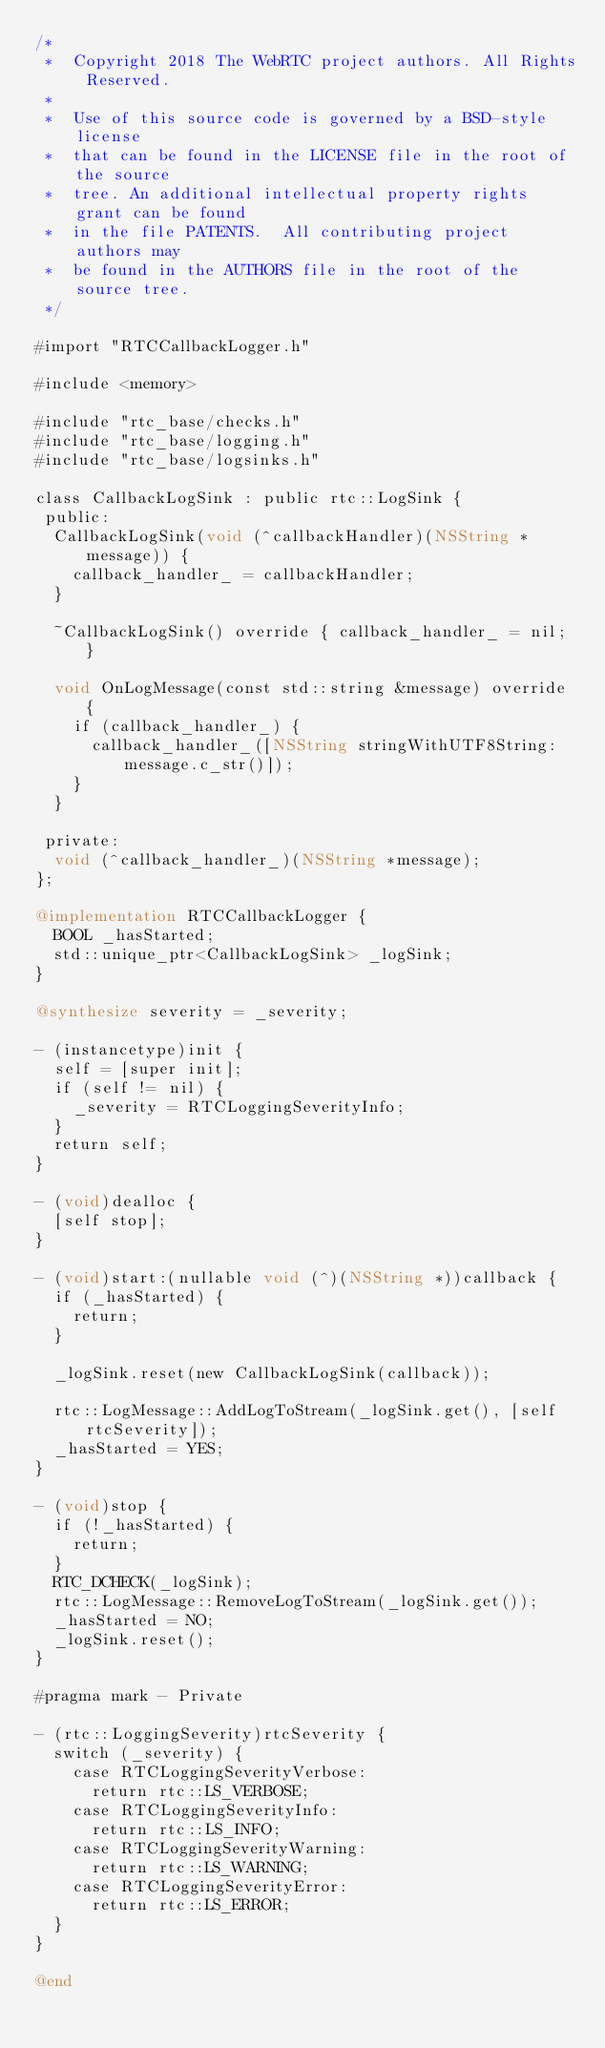<code> <loc_0><loc_0><loc_500><loc_500><_ObjectiveC_>/*
 *  Copyright 2018 The WebRTC project authors. All Rights Reserved.
 *
 *  Use of this source code is governed by a BSD-style license
 *  that can be found in the LICENSE file in the root of the source
 *  tree. An additional intellectual property rights grant can be found
 *  in the file PATENTS.  All contributing project authors may
 *  be found in the AUTHORS file in the root of the source tree.
 */

#import "RTCCallbackLogger.h"

#include <memory>

#include "rtc_base/checks.h"
#include "rtc_base/logging.h"
#include "rtc_base/logsinks.h"

class CallbackLogSink : public rtc::LogSink {
 public:
  CallbackLogSink(void (^callbackHandler)(NSString *message)) {
    callback_handler_ = callbackHandler;
  }

  ~CallbackLogSink() override { callback_handler_ = nil; }

  void OnLogMessage(const std::string &message) override {
    if (callback_handler_) {
      callback_handler_([NSString stringWithUTF8String:message.c_str()]);
    }
  }

 private:
  void (^callback_handler_)(NSString *message);
};

@implementation RTCCallbackLogger {
  BOOL _hasStarted;
  std::unique_ptr<CallbackLogSink> _logSink;
}

@synthesize severity = _severity;

- (instancetype)init {
  self = [super init];
  if (self != nil) {
    _severity = RTCLoggingSeverityInfo;
  }
  return self;
}

- (void)dealloc {
  [self stop];
}

- (void)start:(nullable void (^)(NSString *))callback {
  if (_hasStarted) {
    return;
  }

  _logSink.reset(new CallbackLogSink(callback));

  rtc::LogMessage::AddLogToStream(_logSink.get(), [self rtcSeverity]);
  _hasStarted = YES;
}

- (void)stop {
  if (!_hasStarted) {
    return;
  }
  RTC_DCHECK(_logSink);
  rtc::LogMessage::RemoveLogToStream(_logSink.get());
  _hasStarted = NO;
  _logSink.reset();
}

#pragma mark - Private

- (rtc::LoggingSeverity)rtcSeverity {
  switch (_severity) {
    case RTCLoggingSeverityVerbose:
      return rtc::LS_VERBOSE;
    case RTCLoggingSeverityInfo:
      return rtc::LS_INFO;
    case RTCLoggingSeverityWarning:
      return rtc::LS_WARNING;
    case RTCLoggingSeverityError:
      return rtc::LS_ERROR;
  }
}

@end
</code> 